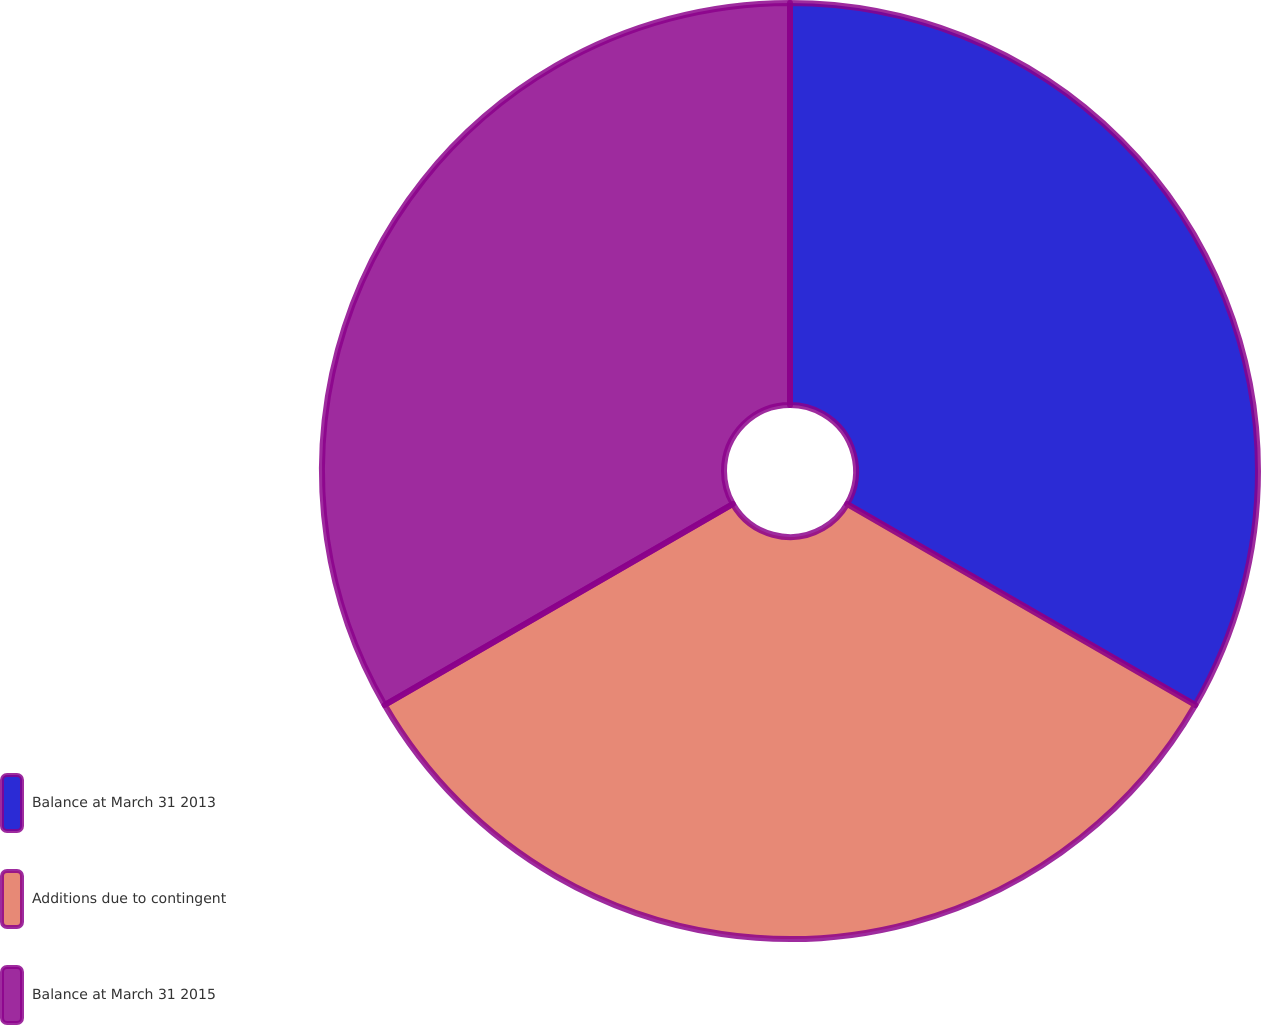<chart> <loc_0><loc_0><loc_500><loc_500><pie_chart><fcel>Balance at March 31 2013<fcel>Additions due to contingent<fcel>Balance at March 31 2015<nl><fcel>33.33%<fcel>33.33%<fcel>33.33%<nl></chart> 